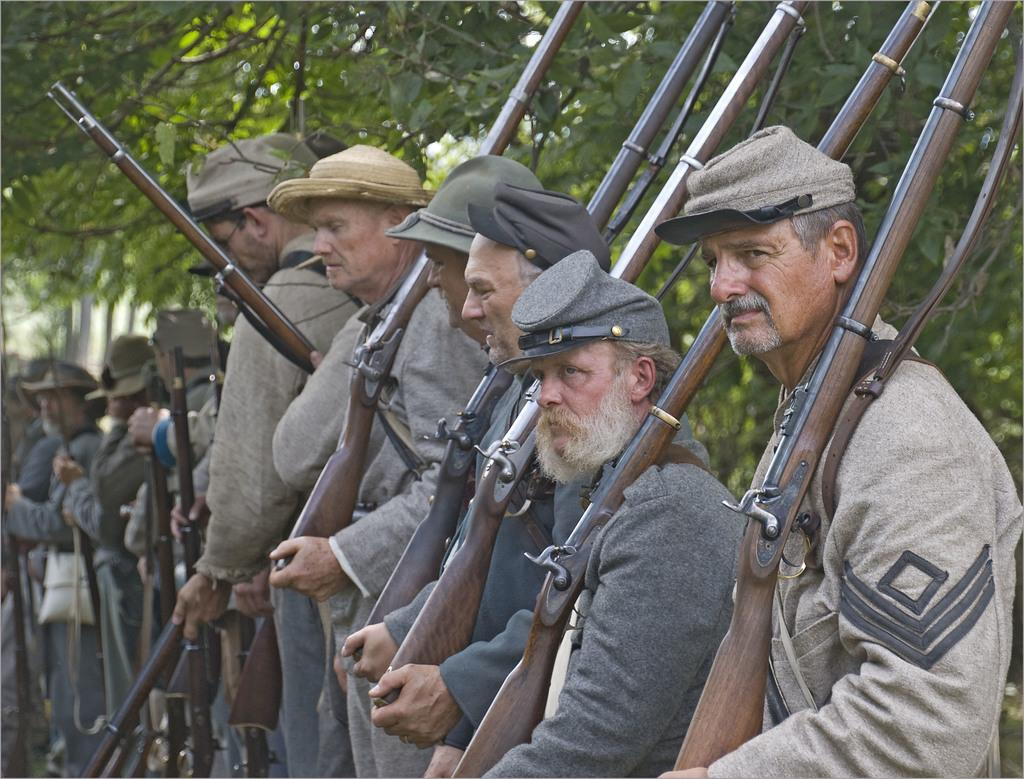Who are the individuals in the image? There are people in the image. What are the people wearing? The people are wearing uniforms and caps. What are the people holding in the image? The people are holding guns. What can be seen in the background of the image? There are trees in the background of the image. What type of mint can be seen growing near the trees in the image? There is no mint visible in the image; only trees are present in the background. Can you describe the wings of the people in the image? The people in the image are not depicted with wings; they are holding guns and wearing uniforms and caps. 